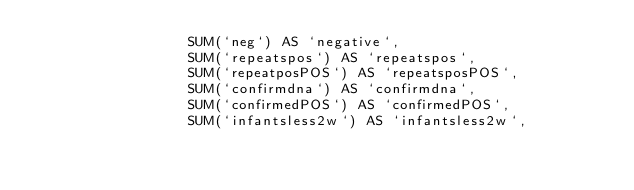Convert code to text. <code><loc_0><loc_0><loc_500><loc_500><_SQL_>                  SUM(`neg`) AS `negative`, 
                  SUM(`repeatspos`) AS `repeatspos`,
                  SUM(`repeatposPOS`) AS `repeatsposPOS`,
                  SUM(`confirmdna`) AS `confirmdna`,
                  SUM(`confirmedPOS`) AS `confirmedPOS`,
                  SUM(`infantsless2w`) AS `infantsless2w`, </code> 